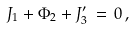<formula> <loc_0><loc_0><loc_500><loc_500>J _ { 1 } + \Phi _ { 2 } + J ^ { \prime } _ { 3 } \, = \, 0 \, ,</formula> 